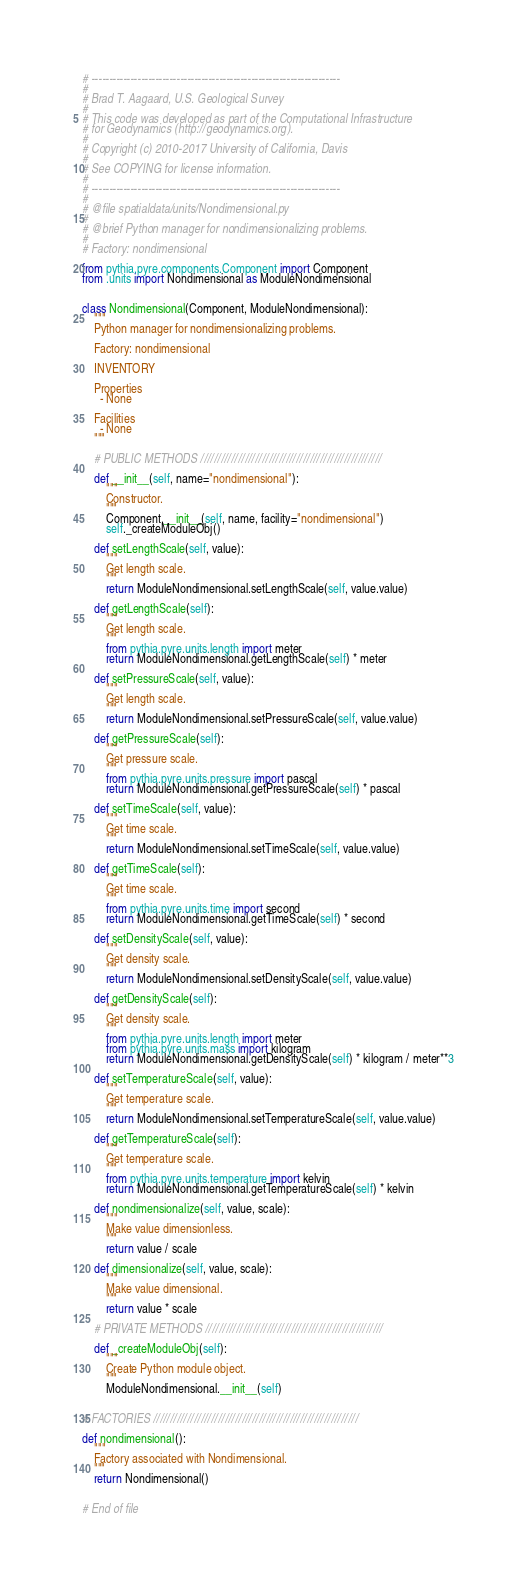Convert code to text. <code><loc_0><loc_0><loc_500><loc_500><_Python_># ----------------------------------------------------------------------
#
# Brad T. Aagaard, U.S. Geological Survey
#
# This code was developed as part of the Computational Infrastructure
# for Geodynamics (http://geodynamics.org).
#
# Copyright (c) 2010-2017 University of California, Davis
#
# See COPYING for license information.
#
# ----------------------------------------------------------------------
#
# @file spatialdata/units/Nondimensional.py
#
# @brief Python manager for nondimensionalizing problems.
#
# Factory: nondimensional

from pythia.pyre.components.Component import Component
from .units import Nondimensional as ModuleNondimensional


class Nondimensional(Component, ModuleNondimensional):
    """
    Python manager for nondimensionalizing problems.

    Factory: nondimensional

    INVENTORY

    Properties
      - None

    Facilities
      - None
    """

    # PUBLIC METHODS /////////////////////////////////////////////////////

    def __init__(self, name="nondimensional"):
        """
        Constructor.
        """
        Component.__init__(self, name, facility="nondimensional")
        self._createModuleObj()

    def setLengthScale(self, value):
        """
        Get length scale.
        """
        return ModuleNondimensional.setLengthScale(self, value.value)

    def getLengthScale(self):
        """
        Get length scale.
        """
        from pythia.pyre.units.length import meter
        return ModuleNondimensional.getLengthScale(self) * meter

    def setPressureScale(self, value):
        """
        Get length scale.
        """
        return ModuleNondimensional.setPressureScale(self, value.value)

    def getPressureScale(self):
        """
        Get pressure scale.
        """
        from pythia.pyre.units.pressure import pascal
        return ModuleNondimensional.getPressureScale(self) * pascal

    def setTimeScale(self, value):
        """
        Get time scale.
        """
        return ModuleNondimensional.setTimeScale(self, value.value)

    def getTimeScale(self):
        """
        Get time scale.
        """
        from pythia.pyre.units.time import second
        return ModuleNondimensional.getTimeScale(self) * second

    def setDensityScale(self, value):
        """
        Get density scale.
        """
        return ModuleNondimensional.setDensityScale(self, value.value)

    def getDensityScale(self):
        """
        Get density scale.
        """
        from pythia.pyre.units.length import meter
        from pythia.pyre.units.mass import kilogram
        return ModuleNondimensional.getDensityScale(self) * kilogram / meter**3

    def setTemperatureScale(self, value):
        """
        Get temperature scale.
        """
        return ModuleNondimensional.setTemperatureScale(self, value.value)

    def getTemperatureScale(self):
        """
        Get temperature scale.
        """
        from pythia.pyre.units.temperature import kelvin
        return ModuleNondimensional.getTemperatureScale(self) * kelvin

    def nondimensionalize(self, value, scale):
        """
        Make value dimensionless.
        """
        return value / scale

    def dimensionalize(self, value, scale):
        """
        Make value dimensional.
        """
        return value * scale

    # PRIVATE METHODS ////////////////////////////////////////////////////

    def _createModuleObj(self):
        """
        Create Python module object.
        """
        ModuleNondimensional.__init__(self)


# FACTORIES ////////////////////////////////////////////////////////////

def nondimensional():
    """
    Factory associated with Nondimensional.
    """
    return Nondimensional()


# End of file
</code> 